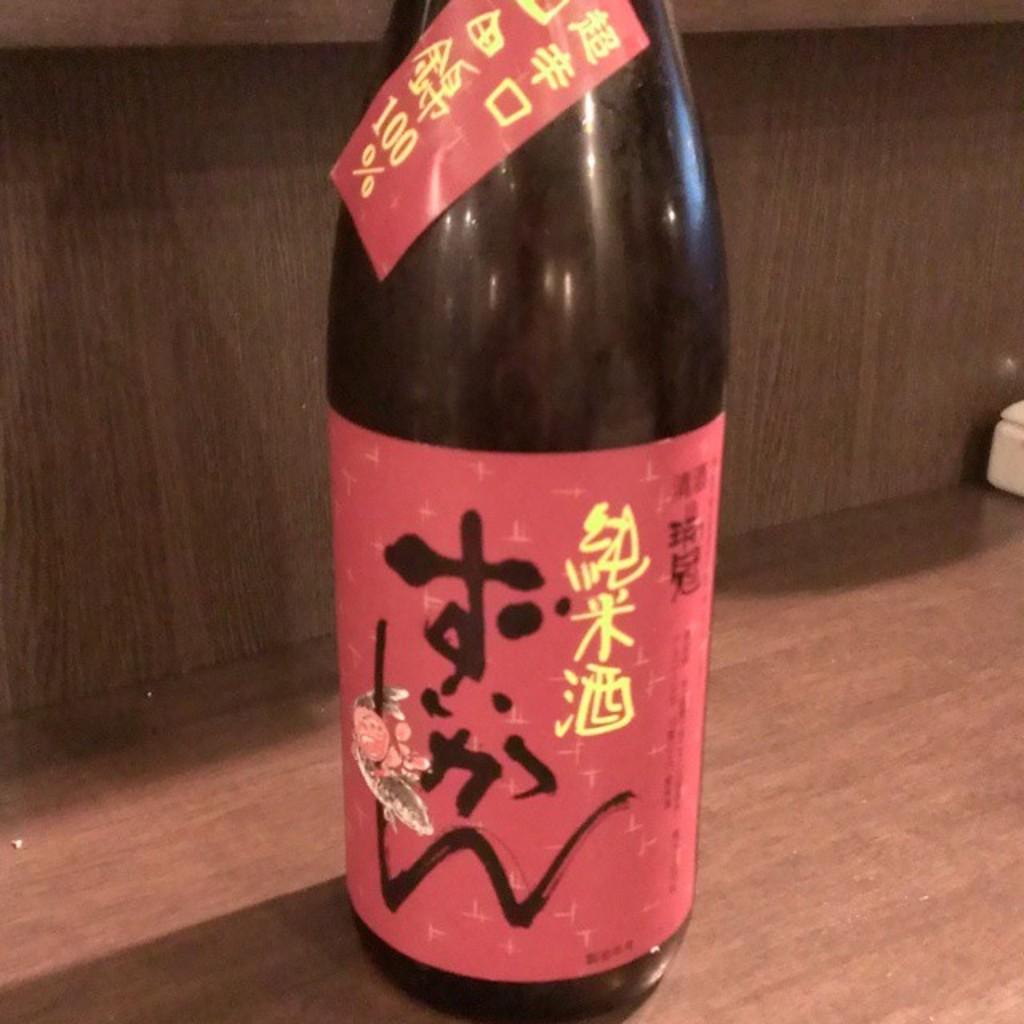What is the % number?
Your answer should be compact. 100. 